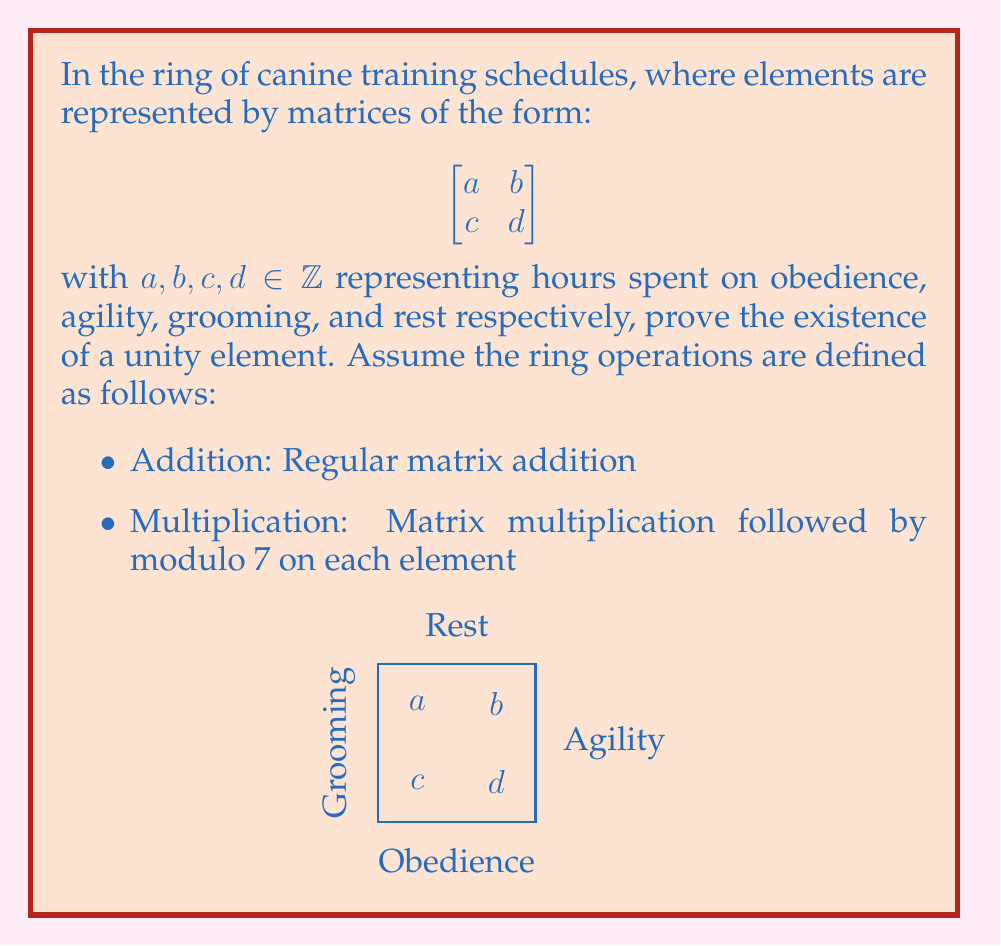Can you solve this math problem? To prove the existence of a unity element in this ring, we need to find a matrix $E$ such that for any matrix $A$ in the ring, $EA = AE = A$.

Let's propose a unity element:

$$E = \begin{bmatrix}
1 & 0 \\
0 & 1
\end{bmatrix}$$

Now, let's verify if this works as the unity element:

1) For any matrix $A = \begin{bmatrix}
a & b \\
c & d
\end{bmatrix}$ in the ring:

   $EA = \begin{bmatrix}
   1 & 0 \\
   0 & 1
   \end{bmatrix} \begin{bmatrix}
   a & b \\
   c & d
   \end{bmatrix} = \begin{bmatrix}
   1a + 0c & 1b + 0d \\
   0a + 1c & 0b + 1d
   \end{bmatrix} = \begin{bmatrix}
   a & b \\
   c & d
   \end{bmatrix} = A$

2) Similarly:
   
   $AE = \begin{bmatrix}
   a & b \\
   c & d
   \end{bmatrix} \begin{bmatrix}
   1 & 0 \\
   0 & 1
   \end{bmatrix} = \begin{bmatrix}
   a1 + b0 & a0 + b1 \\
   c1 + d0 & c0 + d1
   \end{bmatrix} = \begin{bmatrix}
   a & b \\
   c & d
   \end{bmatrix} = A$

3) Note that all elements are already in modulo 7, so no further operation is needed.

Therefore, $E$ is indeed the unity element in this ring, as $EA = AE = A$ for all $A$ in the ring.
Answer: The unity element is $\begin{bmatrix} 1 & 0 \\ 0 & 1 \end{bmatrix}$. 